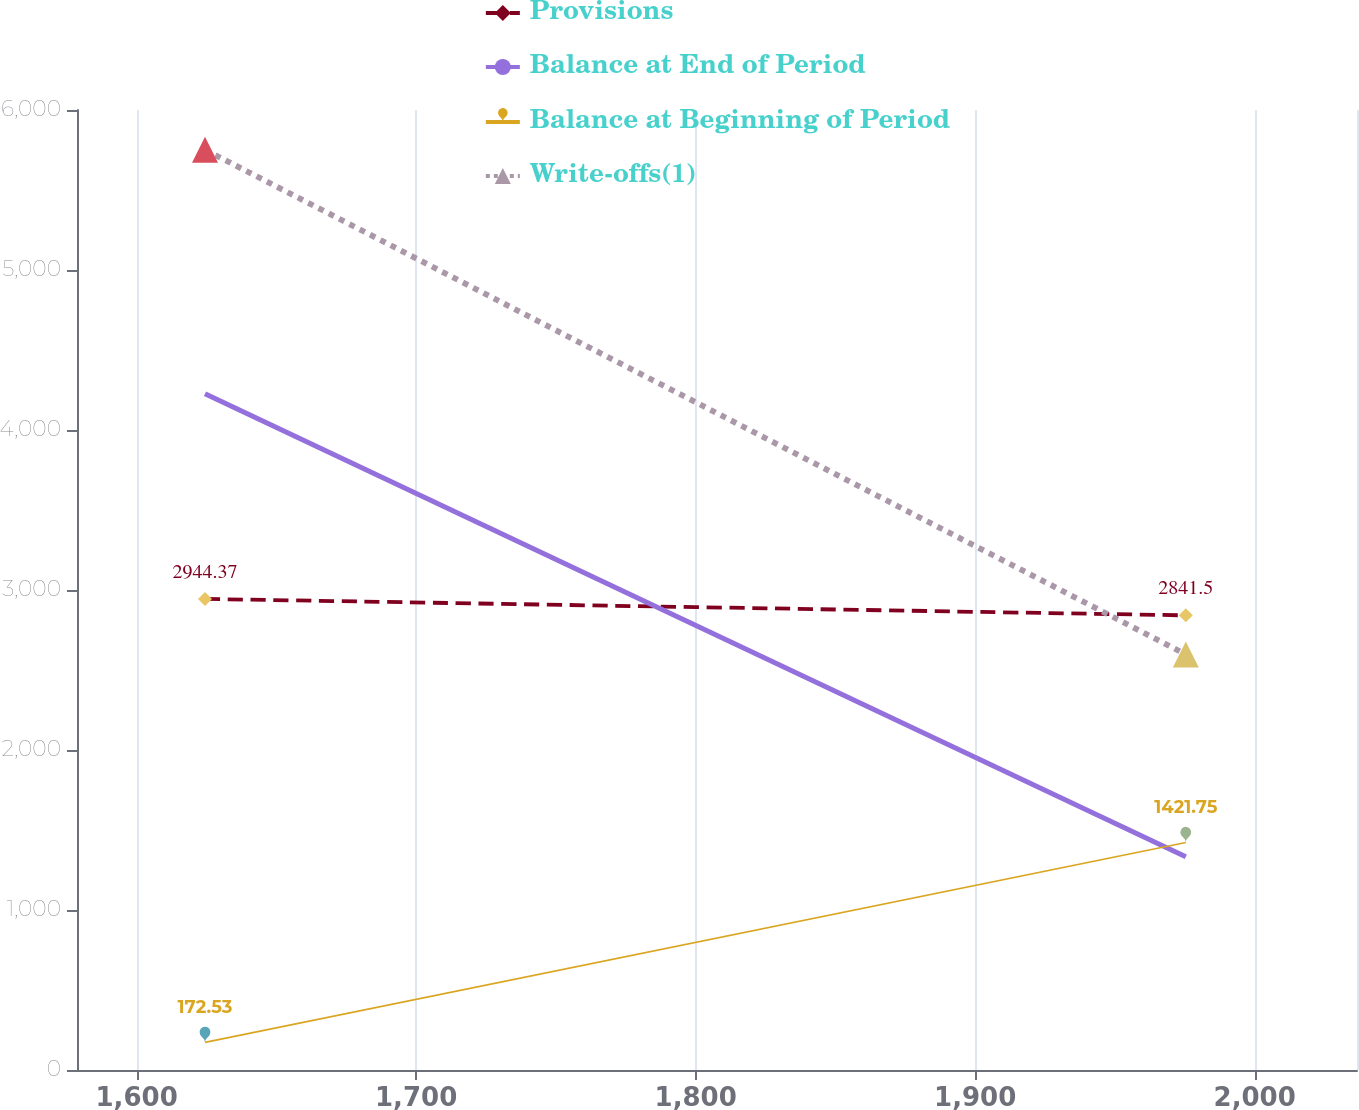Convert chart to OTSL. <chart><loc_0><loc_0><loc_500><loc_500><line_chart><ecel><fcel>Provisions<fcel>Balance at End of Period<fcel>Balance at Beginning of Period<fcel>Write-offs(1)<nl><fcel>1624.46<fcel>2944.37<fcel>4226.81<fcel>172.53<fcel>5751.58<nl><fcel>1975.36<fcel>2841.5<fcel>1333.27<fcel>1421.75<fcel>2597.38<nl><fcel>2082.4<fcel>3870.18<fcel>1011.77<fcel>33.73<fcel>2246.91<nl></chart> 